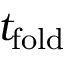Convert formula to latex. <formula><loc_0><loc_0><loc_500><loc_500>t _ { f o l d }</formula> 